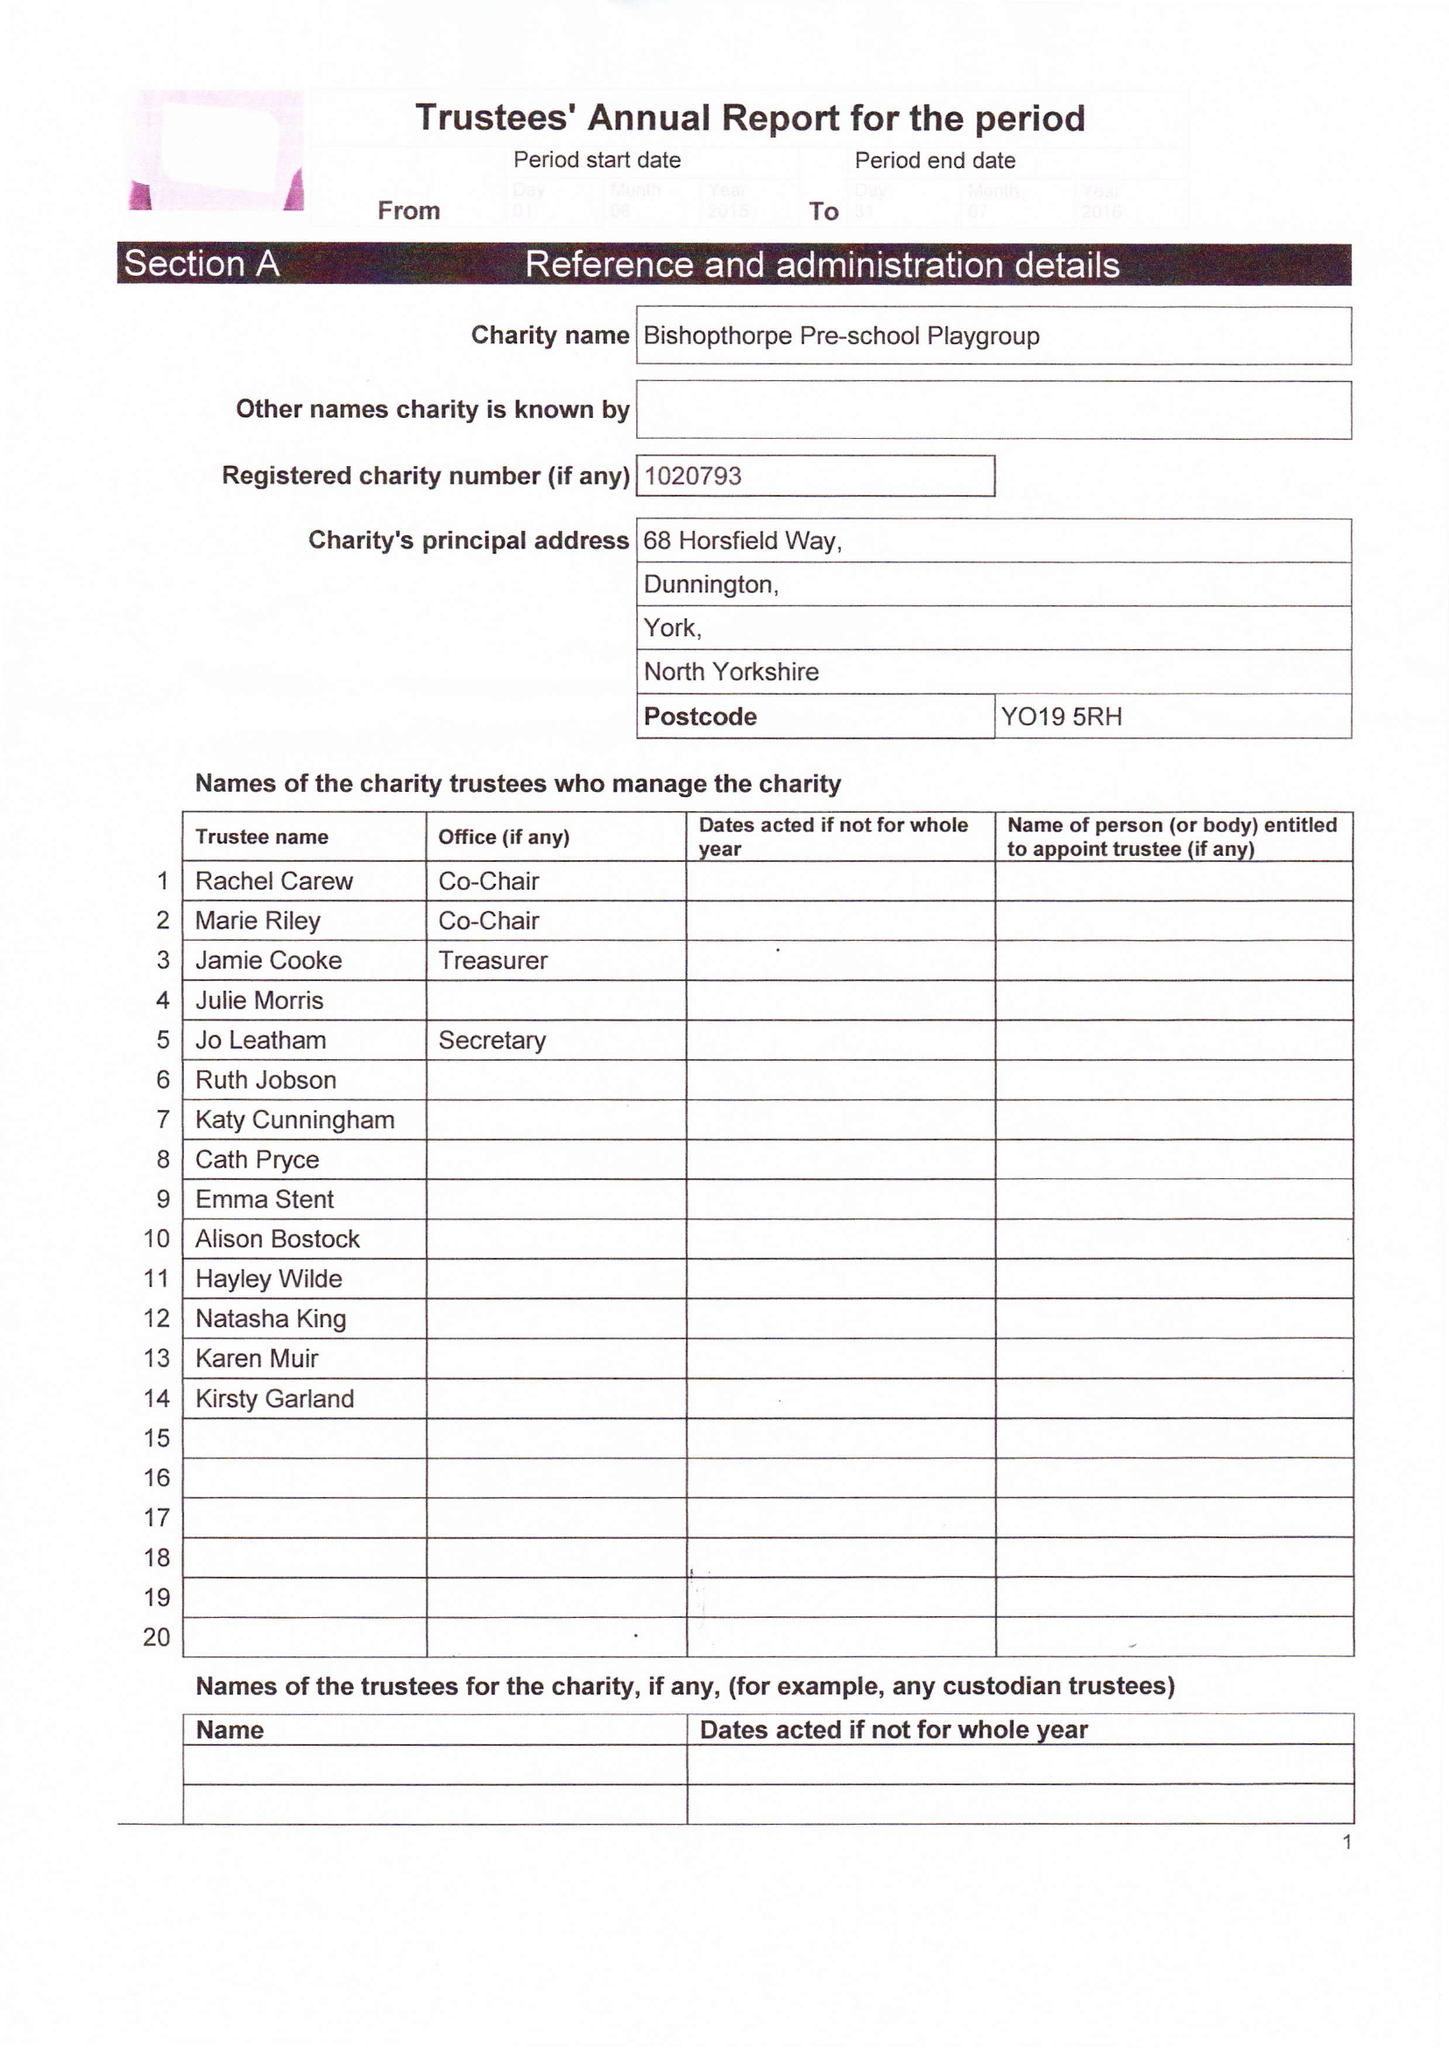What is the value for the charity_number?
Answer the question using a single word or phrase. 1020793 